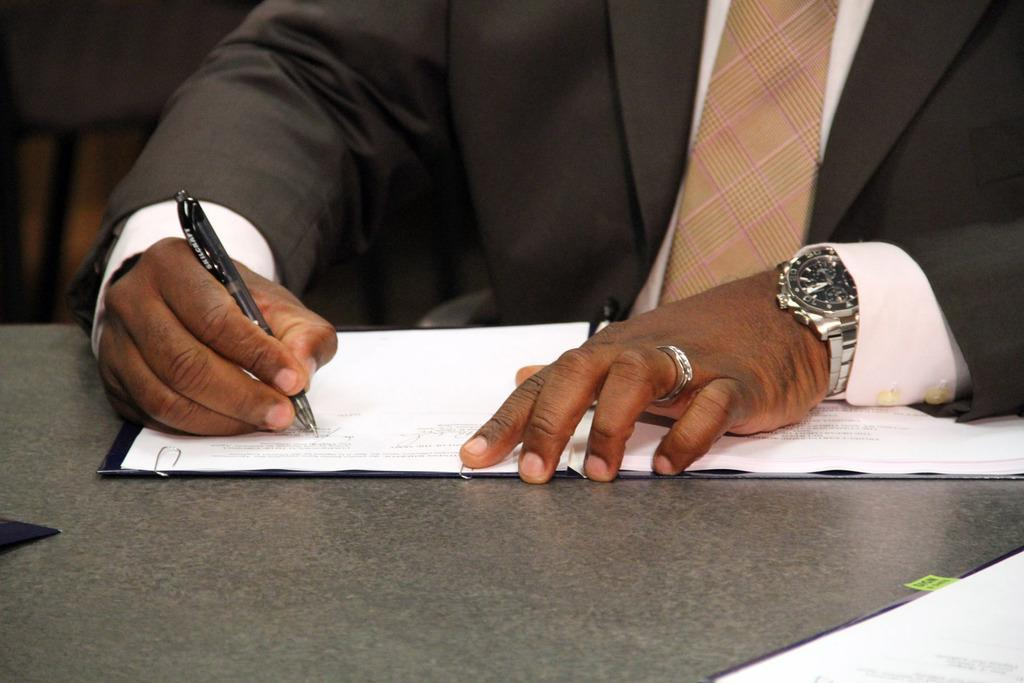What is the main subject of the image? There is a person in the image. What is the person holding in his hand? The person is holding a pen in his hand. What can be seen in the foreground of the image? There are books placed on a surface in the foreground of the image. What type of carriage can be seen in the background of the image? There is no carriage present in the image. How does the beef appear in the image? There is no beef present in the image. 